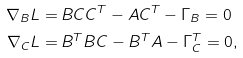<formula> <loc_0><loc_0><loc_500><loc_500>\nabla _ { B } L = \, & B C C ^ { T } - A C ^ { T } - \Gamma _ { B } = 0 \\ \nabla _ { C } L = \, & B ^ { T } B C - B ^ { T } A - \Gamma _ { C } ^ { T } = 0 ,</formula> 